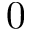<formula> <loc_0><loc_0><loc_500><loc_500>0</formula> 